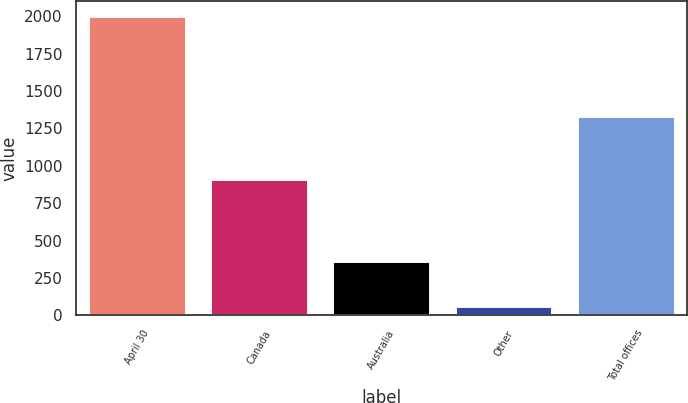Convert chart. <chart><loc_0><loc_0><loc_500><loc_500><bar_chart><fcel>April 30<fcel>Canada<fcel>Australia<fcel>Other<fcel>Total offices<nl><fcel>2003<fcel>910<fcel>362<fcel>62<fcel>1334<nl></chart> 